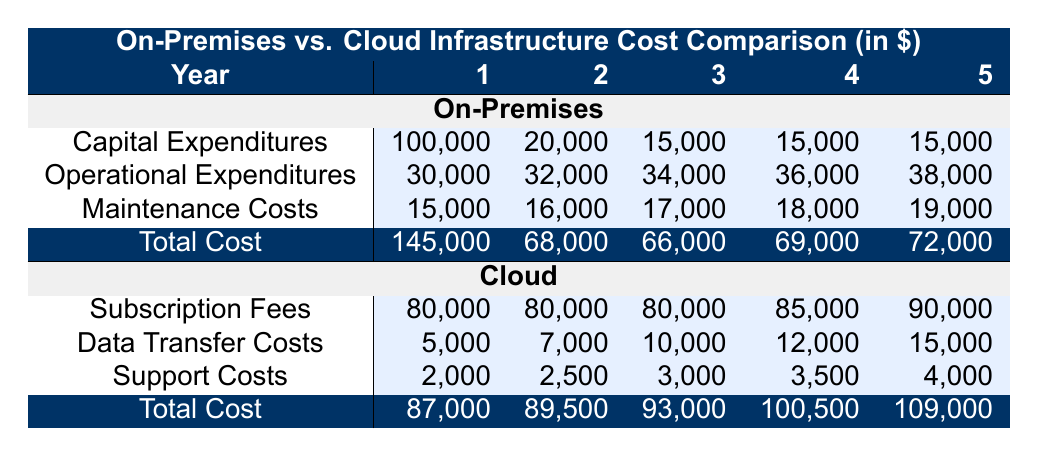What is the total cost of on-premises infrastructure in Year 1? The table shows that the total cost of on-premises infrastructure in Year 1 is listed under the "Total Cost" row for on-premises, which is 145,000.
Answer: 145000 What are the operational expenditures for cloud infrastructure in Year 3? Looking at the table, the operational expenditures for cloud in Year 3 are not directly provided, but we can check the "Subscription Fees," "Data Transfer Costs," and "Support Costs," which are 80,000, 10,000, and 3,000 respectively. However, since operational expenditures are not explicitly shown for the cloud, we can conclude it is not available here.
Answer: Not available What is the difference in total cost between on-premises and cloud in Year 2? For Year 2, on-premises total cost is 68,000, and cloud total cost is 89,500. The difference is calculated as 89,500 - 68,000, which equals 21,500.
Answer: 21500 Is the total cost for cloud infrastructure greater than the total cost for on-premises in Year 5? In Year 5, the total cost for on-premises is 72,000, while the total cost for cloud is 109,000. Since 109,000 is greater than 72,000, the answer is yes.
Answer: Yes What is the average total cost for on-premises infrastructure over the 5-year period? To find the average, we need to sum the total costs for each year: 145,000 + 68,000 + 66,000 + 69,000 + 72,000 = 420,000. Then we divide by 5 years: 420,000 / 5 = 84,000.
Answer: 84000 What was the highest capital expenditure recorded for on-premises infrastructure? In the table, we can see that the capital expenditure for on-premises in Year 1 is 100,000, which is higher than any other year listed (20,000 for Year 2, and 15,000 for Years 3, 4, and 5). Thus, the highest capital expenditure is 100,000.
Answer: 100000 What was the trend for maintenance costs in the on-premises infrastructure over the 5 years? By reviewing the maintenance costs: Year 1: 15,000, Year 2: 16,000, Year 3: 17,000, Year 4: 18,000, Year 5: 19,000, we see that these numbers consistently increase each year, indicating a trend of rising costs.
Answer: Increasing What are the combined subscription fees of cloud infrastructure over the 5 years? The subscription fees for cloud over the years are: Year 1: 80,000, Year 2: 80,000, Year 3: 80,000, Year 4: 85,000, Year 5: 90,000. Adding these together gives us 80,000 + 80,000 + 80,000 + 85,000 + 90,000 = 415,000.
Answer: 415000 Is it true that the operational expenditures for on-premises always increase year over year? Reviewing the operational expenditures for the years: Year 1: 30,000, Year 2: 32,000, Year 3: 34,000, Year 4: 36,000, and Year 5: 38,000, we can see that they consistently rise. Therefore, it is true the operational expenditures always increase.
Answer: True 